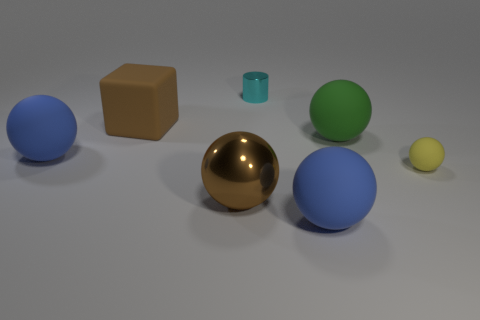There is a blue object right of the large blue rubber thing that is on the left side of the big block that is in front of the tiny cyan metallic cylinder; what is its shape?
Your response must be concise. Sphere. What number of rubber objects have the same shape as the small cyan metal thing?
Offer a terse response. 0. There is a sphere that is the same color as the big rubber block; what material is it?
Give a very brief answer. Metal. Do the yellow ball and the brown block have the same material?
Ensure brevity in your answer.  Yes. How many big brown rubber things are in front of the blue ball behind the large brown thing in front of the big green thing?
Provide a short and direct response. 0. Are there any large balls made of the same material as the large green object?
Ensure brevity in your answer.  Yes. The metal ball that is the same color as the cube is what size?
Give a very brief answer. Large. Are there fewer large blue objects than yellow spheres?
Ensure brevity in your answer.  No. There is a shiny thing in front of the brown rubber object; is its color the same as the block?
Provide a succinct answer. Yes. What material is the tiny thing that is behind the blue sphere behind the sphere in front of the large brown ball?
Your response must be concise. Metal. 